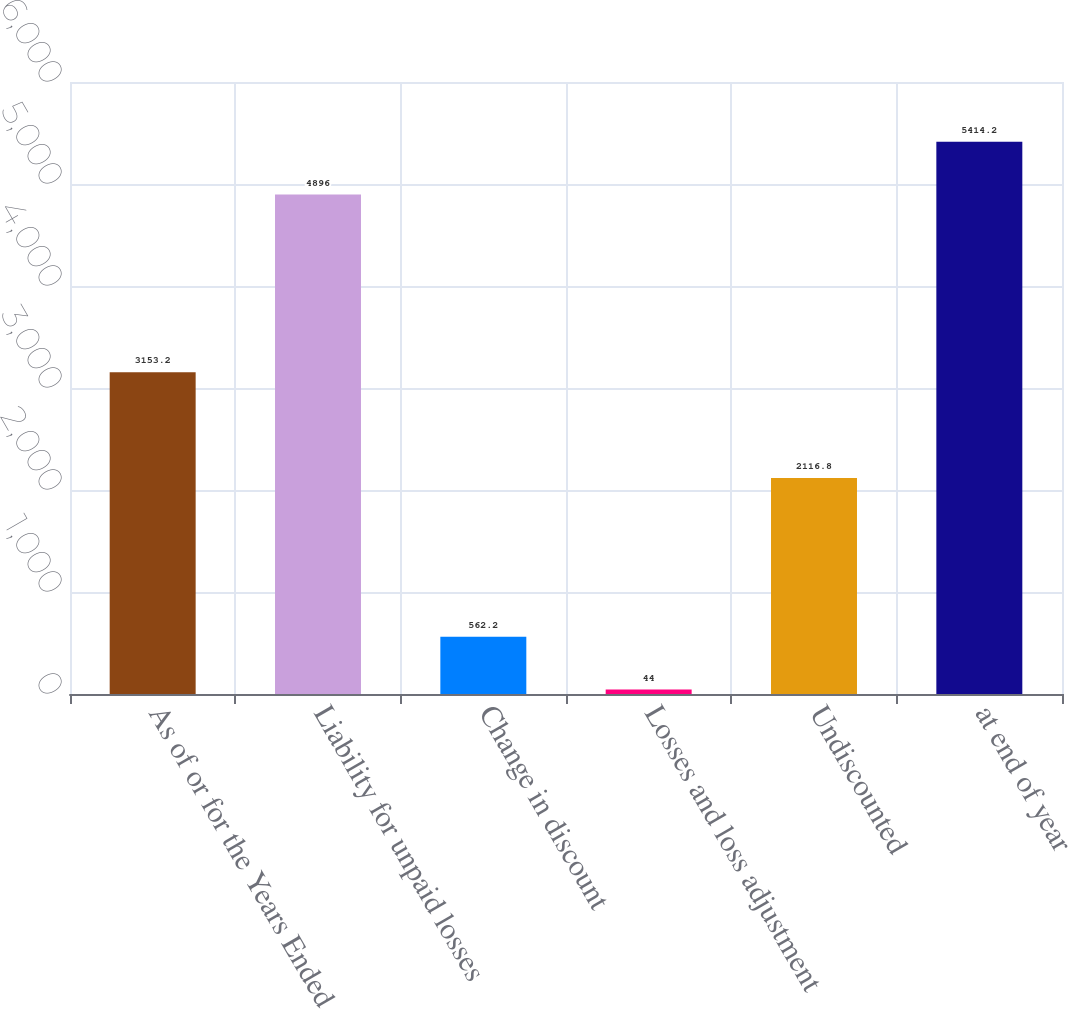<chart> <loc_0><loc_0><loc_500><loc_500><bar_chart><fcel>As of or for the Years Ended<fcel>Liability for unpaid losses<fcel>Change in discount<fcel>Losses and loss adjustment<fcel>Undiscounted<fcel>at end of year<nl><fcel>3153.2<fcel>4896<fcel>562.2<fcel>44<fcel>2116.8<fcel>5414.2<nl></chart> 